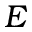<formula> <loc_0><loc_0><loc_500><loc_500>E</formula> 